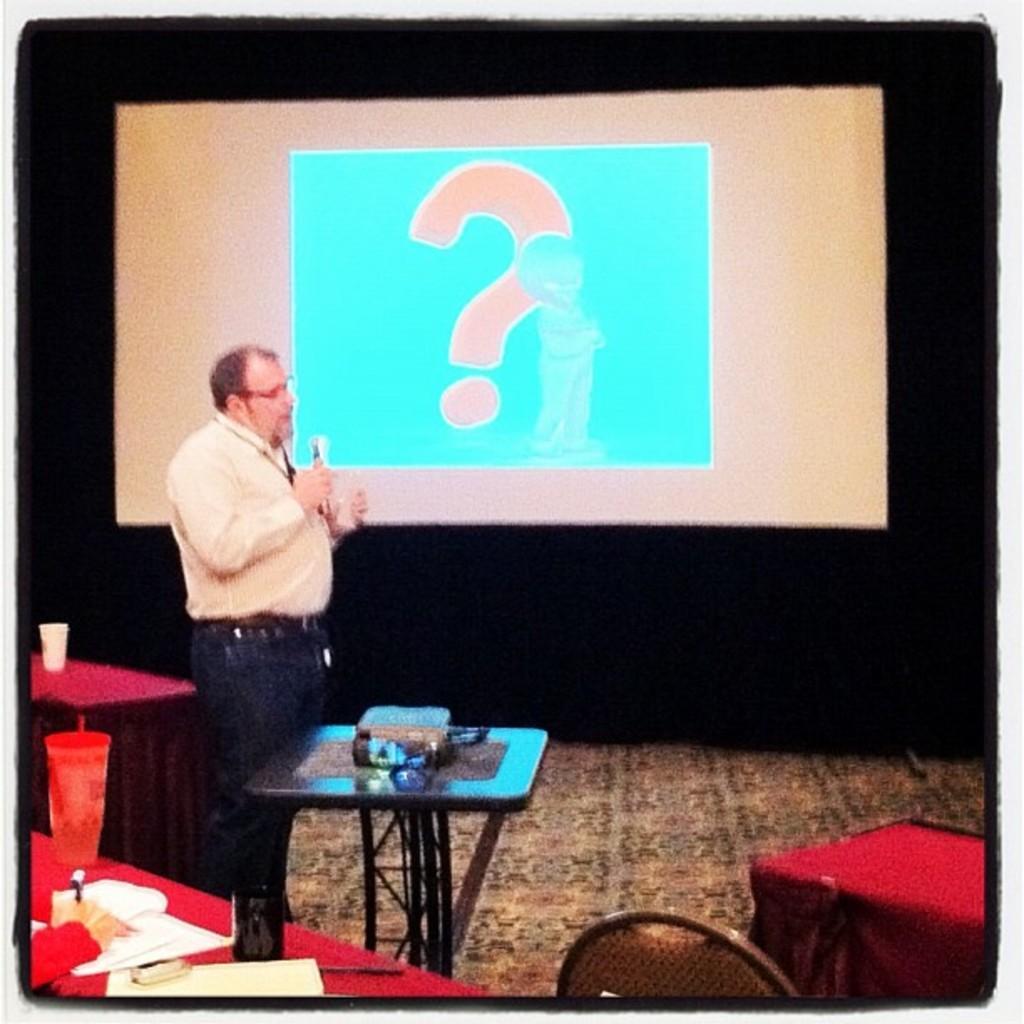Please provide a concise description of this image. In this image we can see a person holding a mic, and talking in it, in front with him there is a table with some objects on it, aside to him there are some other tables, on those tables we can see some papers, and a glass, there is a chair and a person's hand, also we can see a screen, with a question mark symbol on it. 